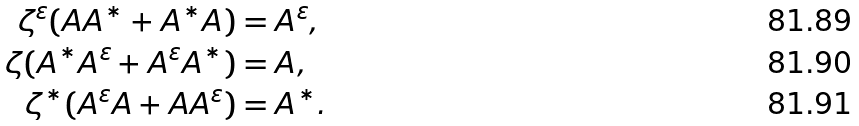<formula> <loc_0><loc_0><loc_500><loc_500>\zeta ^ { \varepsilon } ( A A ^ { * } + A ^ { * } A ) & = A ^ { \varepsilon } , \\ \zeta ( A ^ { * } A ^ { \varepsilon } + A ^ { \varepsilon } A ^ { * } ) & = A , \\ \zeta ^ { * } ( A ^ { \varepsilon } A + A A ^ { \varepsilon } ) & = A ^ { * } .</formula> 